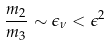<formula> <loc_0><loc_0><loc_500><loc_500>\frac { m _ { 2 } } { m _ { 3 } } \sim \epsilon _ { \nu } < \epsilon ^ { 2 }</formula> 